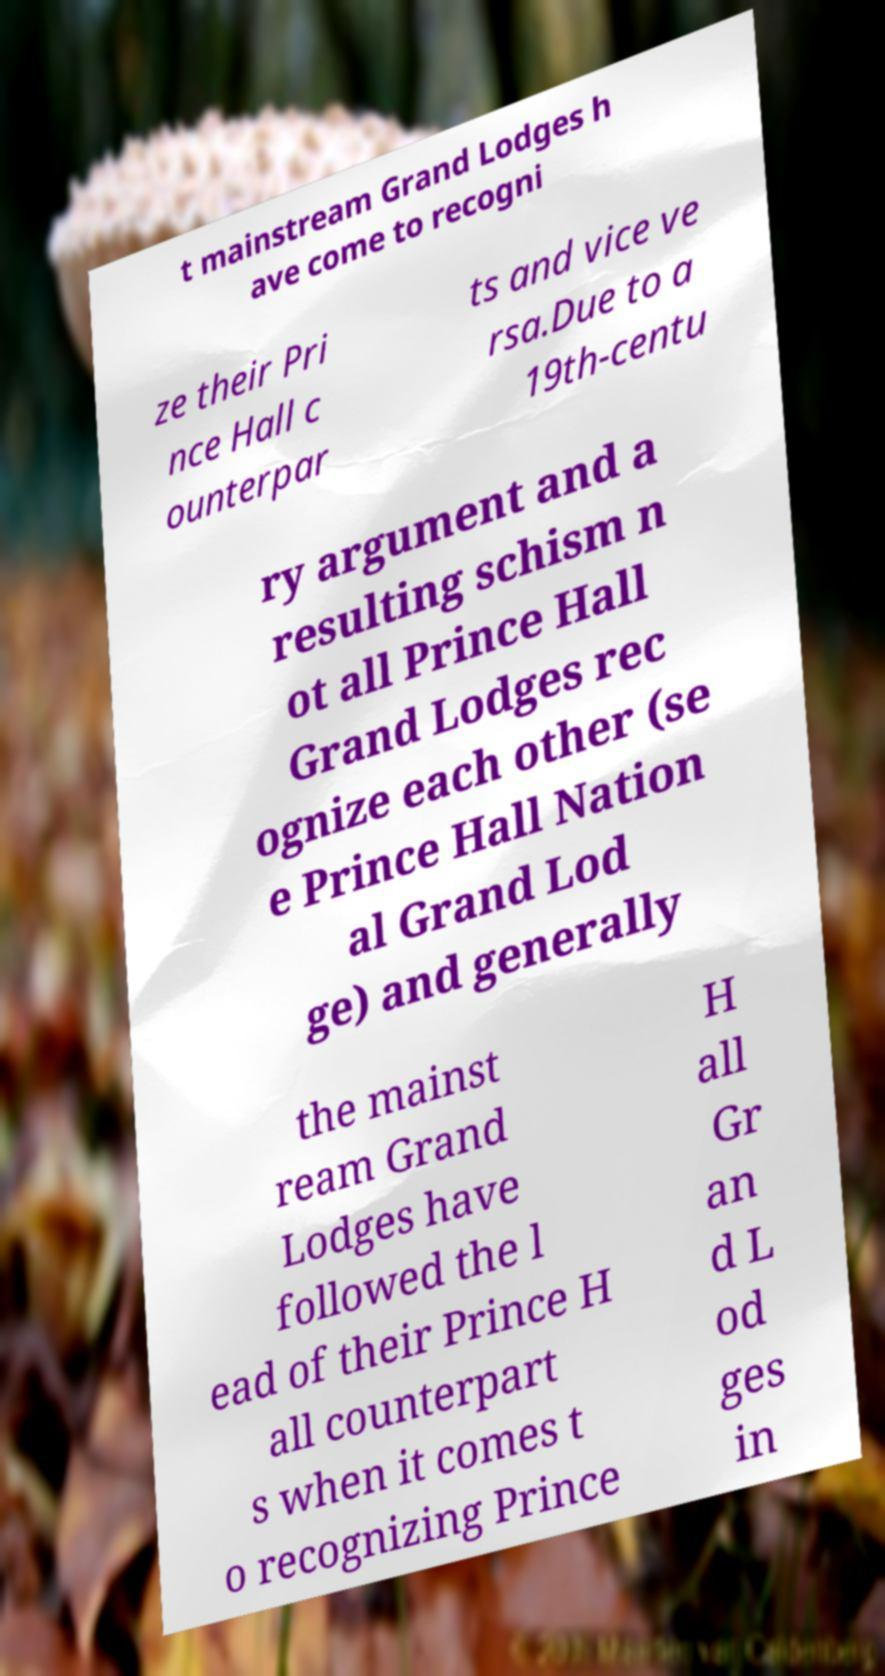Could you extract and type out the text from this image? t mainstream Grand Lodges h ave come to recogni ze their Pri nce Hall c ounterpar ts and vice ve rsa.Due to a 19th-centu ry argument and a resulting schism n ot all Prince Hall Grand Lodges rec ognize each other (se e Prince Hall Nation al Grand Lod ge) and generally the mainst ream Grand Lodges have followed the l ead of their Prince H all counterpart s when it comes t o recognizing Prince H all Gr an d L od ges in 